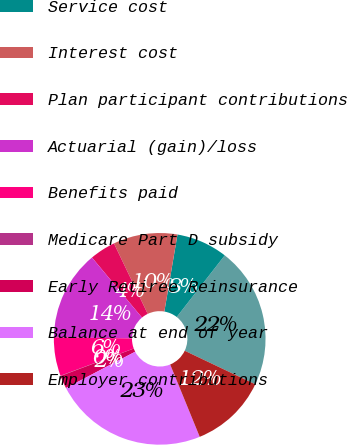Convert chart to OTSL. <chart><loc_0><loc_0><loc_500><loc_500><pie_chart><fcel>Balance at beginning of year<fcel>Service cost<fcel>Interest cost<fcel>Plan participant contributions<fcel>Actuarial (gain)/loss<fcel>Benefits paid<fcel>Medicare Part D subsidy<fcel>Early Retiree Reinsurance<fcel>Balance at end of year<fcel>Employer contributions<nl><fcel>21.53%<fcel>7.85%<fcel>9.8%<fcel>3.94%<fcel>13.71%<fcel>5.9%<fcel>0.04%<fcel>1.99%<fcel>23.48%<fcel>11.76%<nl></chart> 